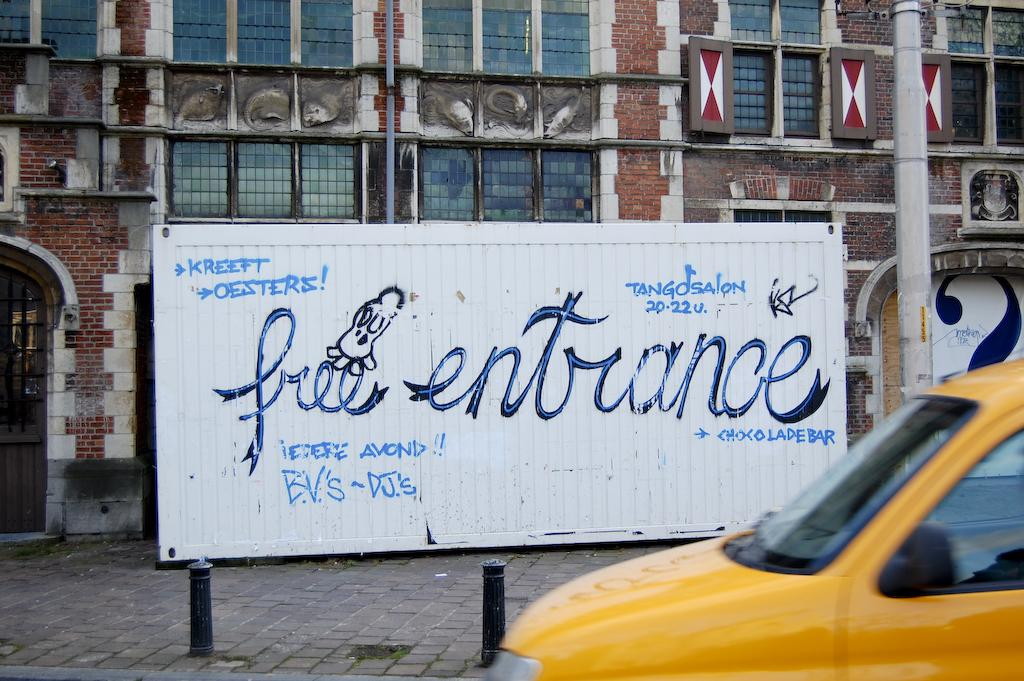<image>
Share a concise interpretation of the image provided. "free entrance" is painted on a white board. 